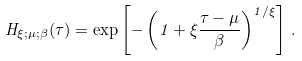Convert formula to latex. <formula><loc_0><loc_0><loc_500><loc_500>H _ { \xi ; \mu ; \beta } ( \tau ) = \exp \left [ - \left ( 1 + \xi \frac { \tau - \mu } { \beta } \right ) ^ { 1 / \xi } \right ] \, .</formula> 